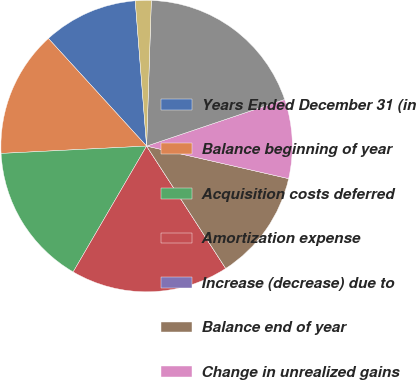Convert chart to OTSL. <chart><loc_0><loc_0><loc_500><loc_500><pie_chart><fcel>Years Ended December 31 (in<fcel>Balance beginning of year<fcel>Acquisition costs deferred<fcel>Amortization expense<fcel>Increase (decrease) due to<fcel>Balance end of year<fcel>Change in unrealized gains<fcel>Subtotal<fcel>Consolidation and eliminations<nl><fcel>10.53%<fcel>14.03%<fcel>15.79%<fcel>17.54%<fcel>0.0%<fcel>12.28%<fcel>8.77%<fcel>19.3%<fcel>1.76%<nl></chart> 